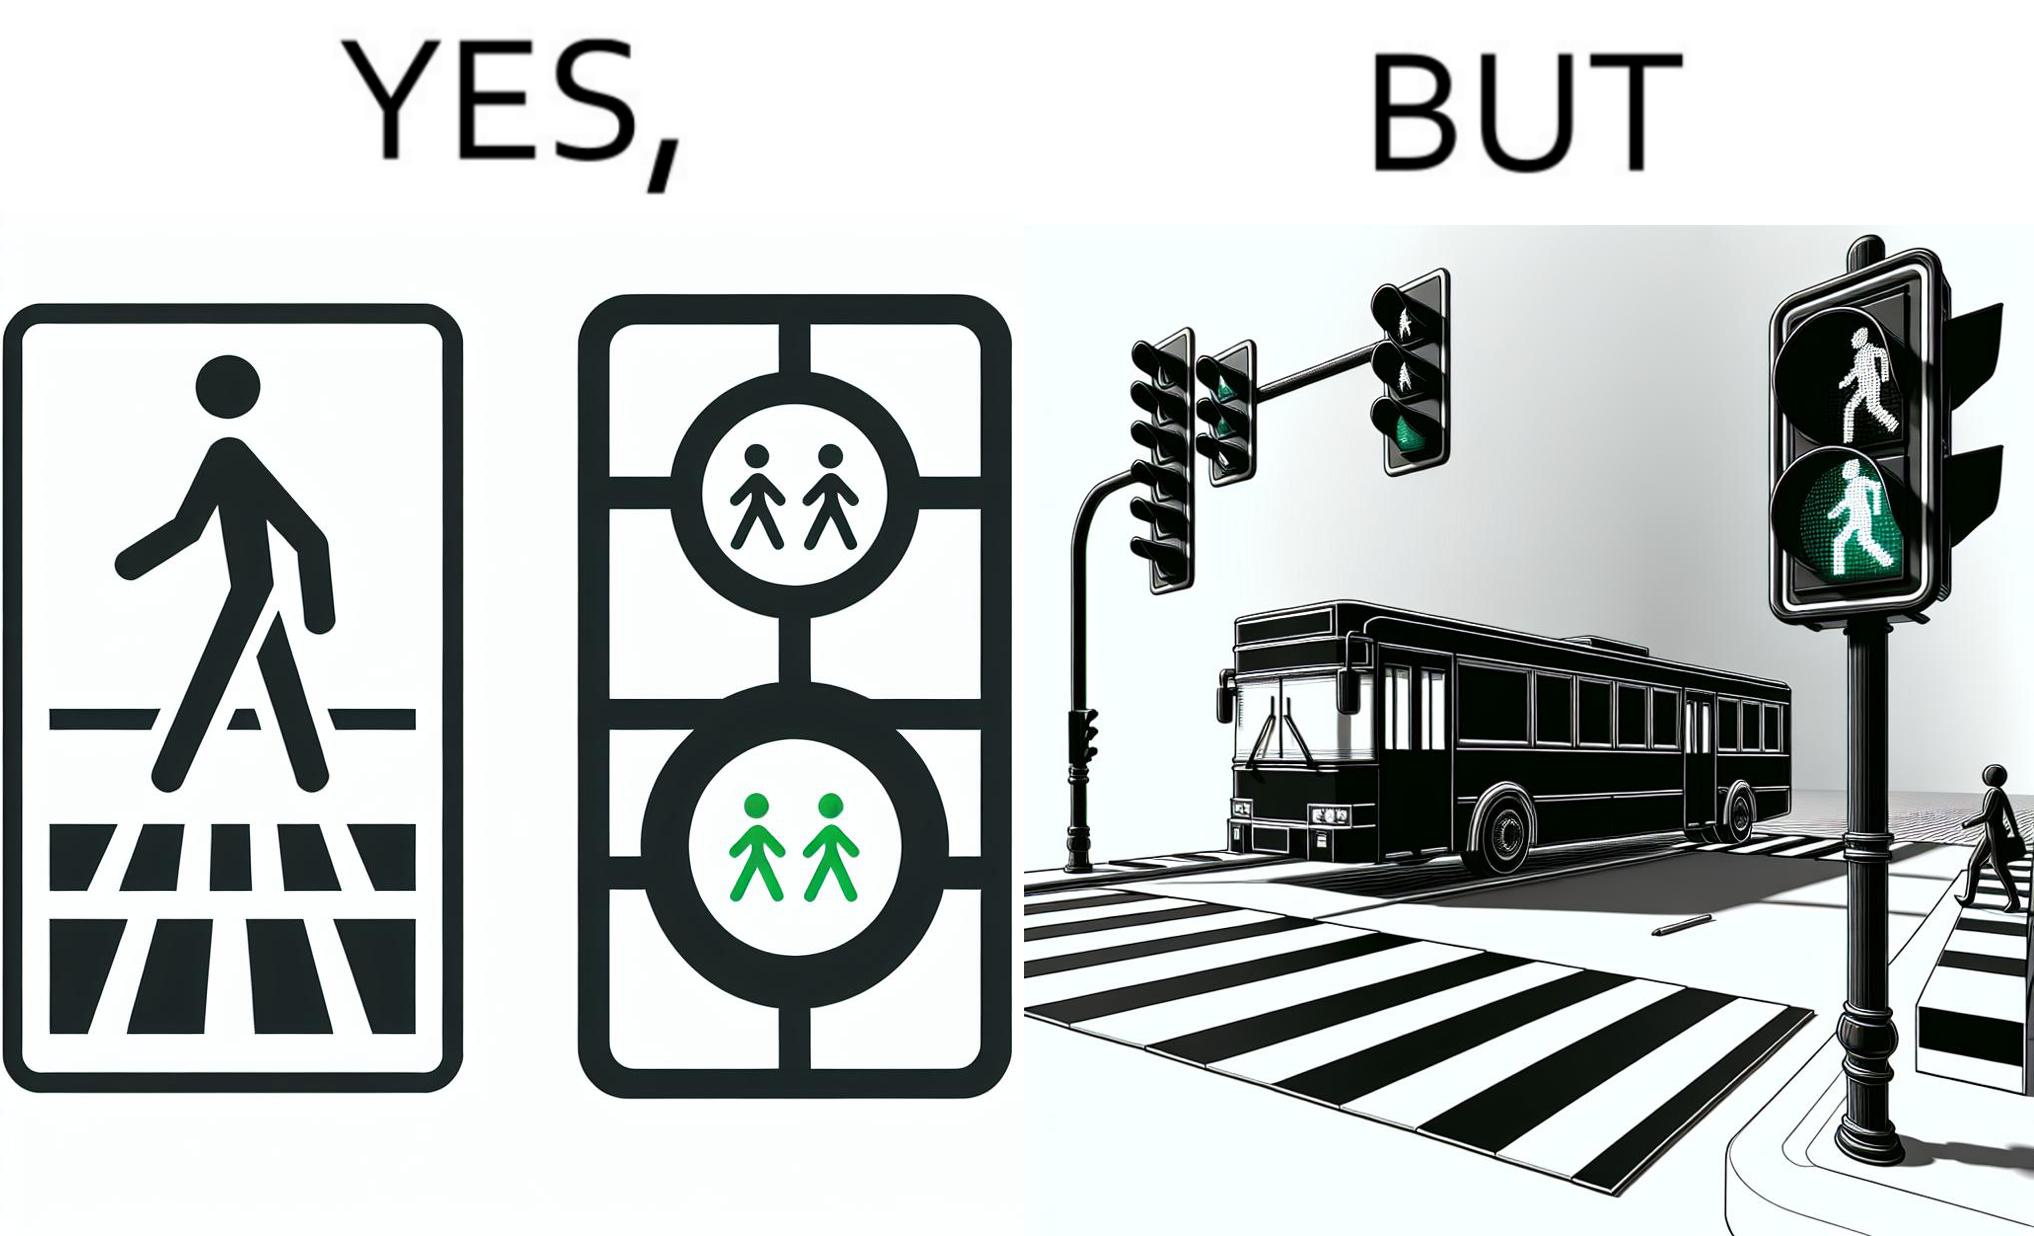Why is this image considered satirical? The image is ironic, because even when the signal is green for the pedestrians but they can't cross the road because of the vehicles standing on the zebra crossing 